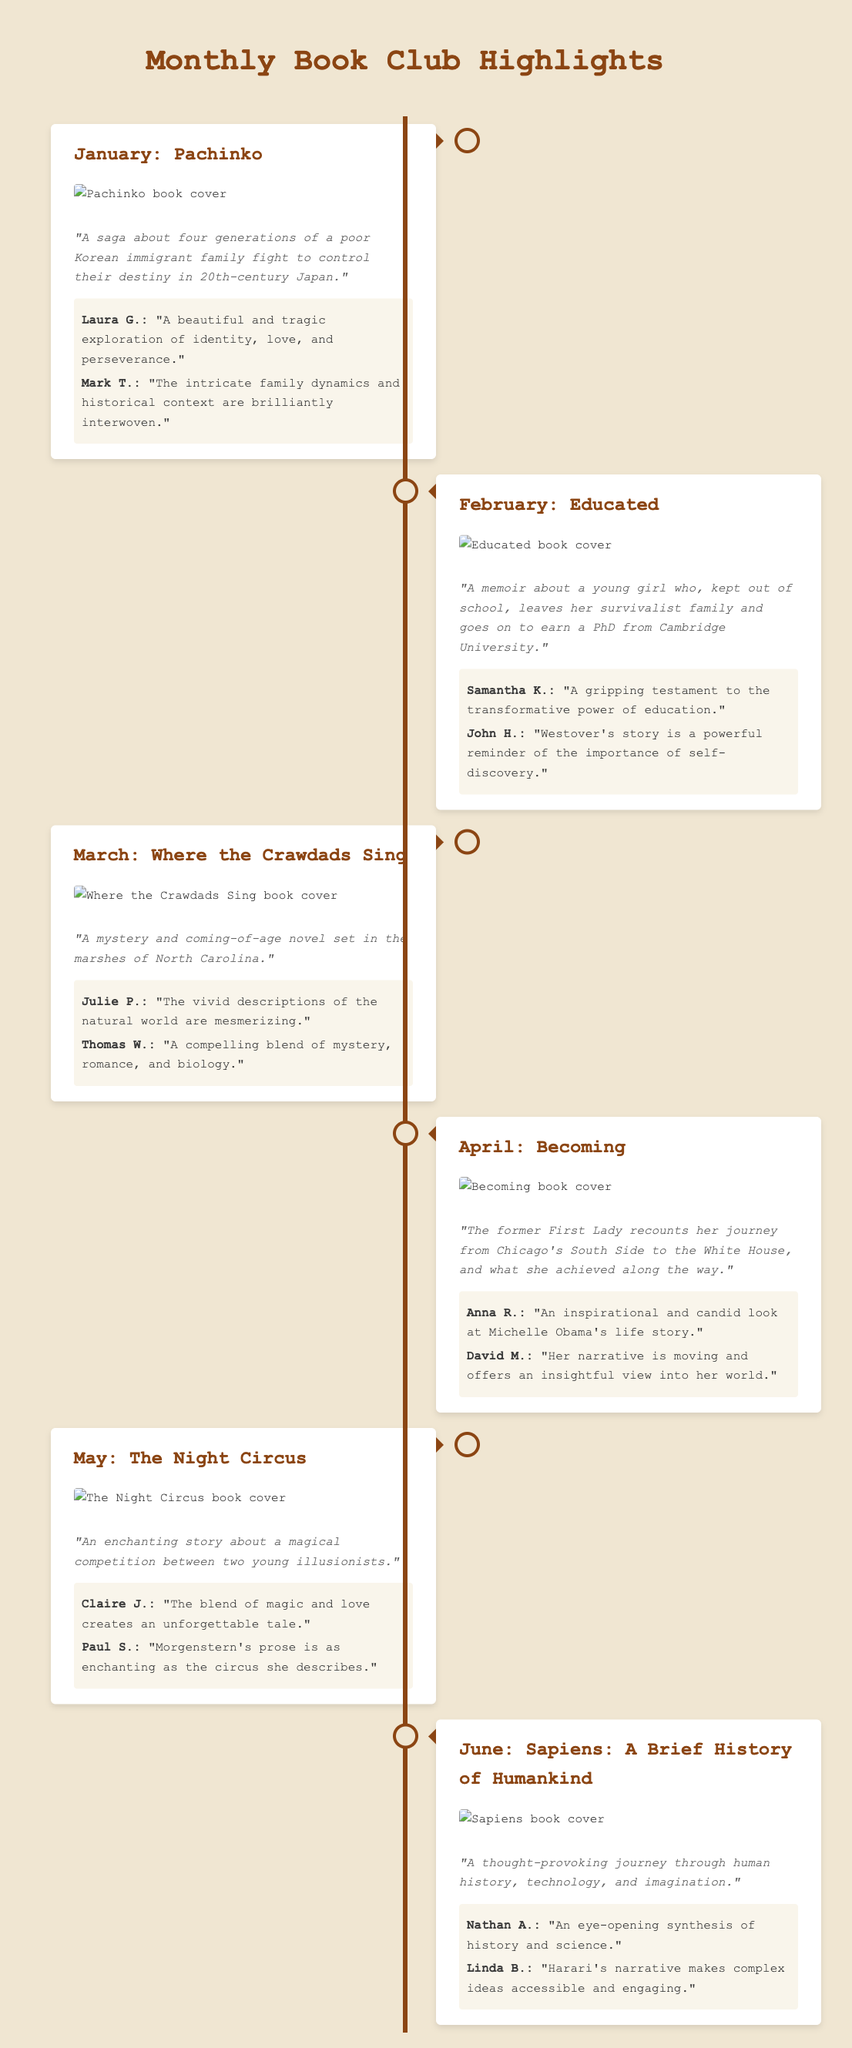What was the featured book in January? The document lists "Pachinko" as the book featured in January.
Answer: Pachinko Who wrote "Educated"? The document does not explicitly name the author, but "Educated" is widely known to be written by Tara Westover.
Answer: Tara Westover Which month featured "Where the Crawdads Sing"? According to the timeline, "Where the Crawdads Sing" was featured in March.
Answer: March What is a key theme in "Becoming"? The insights provided indicate that key themes include inspiration and personal journey.
Answer: Inspiration How many books are highlighted in this timeline? The document counts a total of six featured books within the timeline.
Answer: Six Which month highlighted a book about human history? "Sapiens: A Brief History of Humankind," addressing human history, was featured in June.
Answer: June What genre does "The Night Circus" belong to? Based on the description, "The Night Circus" is characterized as a magical competition, indicating it is likely a fantasy novel.
Answer: Fantasy Who described "Pachinko" as a beautiful exploration? Laura G. remarked that "Pachinko" is a beautiful and tragic exploration of identity.
Answer: Laura G What popular format does the document represent? This document represents a timeline format, highlighting monthly book club activities.
Answer: Timeline 